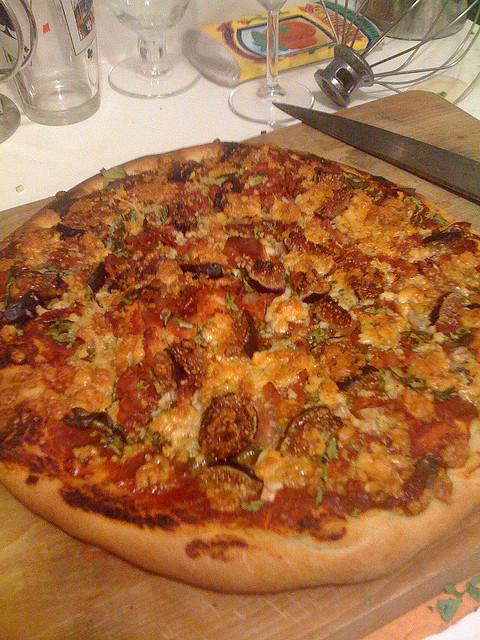Does this pizza contain sausage?
Be succinct. Yes. Is the pizza cut?
Be succinct. No. Does the pizza have black olives on it?
Give a very brief answer. No. Besides the pizza what else is on the table?
Keep it brief. Knife. Is this a deep dish pizza?
Short answer required. No. Is the pizza burnt?
Be succinct. No. What is one clue that this is a fairly recent photo?
Concise answer only. Color. Is the pizza full?
Write a very short answer. Yes. Are there any wine glasses next to the pizza?
Answer briefly. Yes. What is the pizza on?
Answer briefly. Cutting board. What utensil is sitting next to the food?
Quick response, please. Knife. What is laying beside the pizza?
Write a very short answer. Knife. 